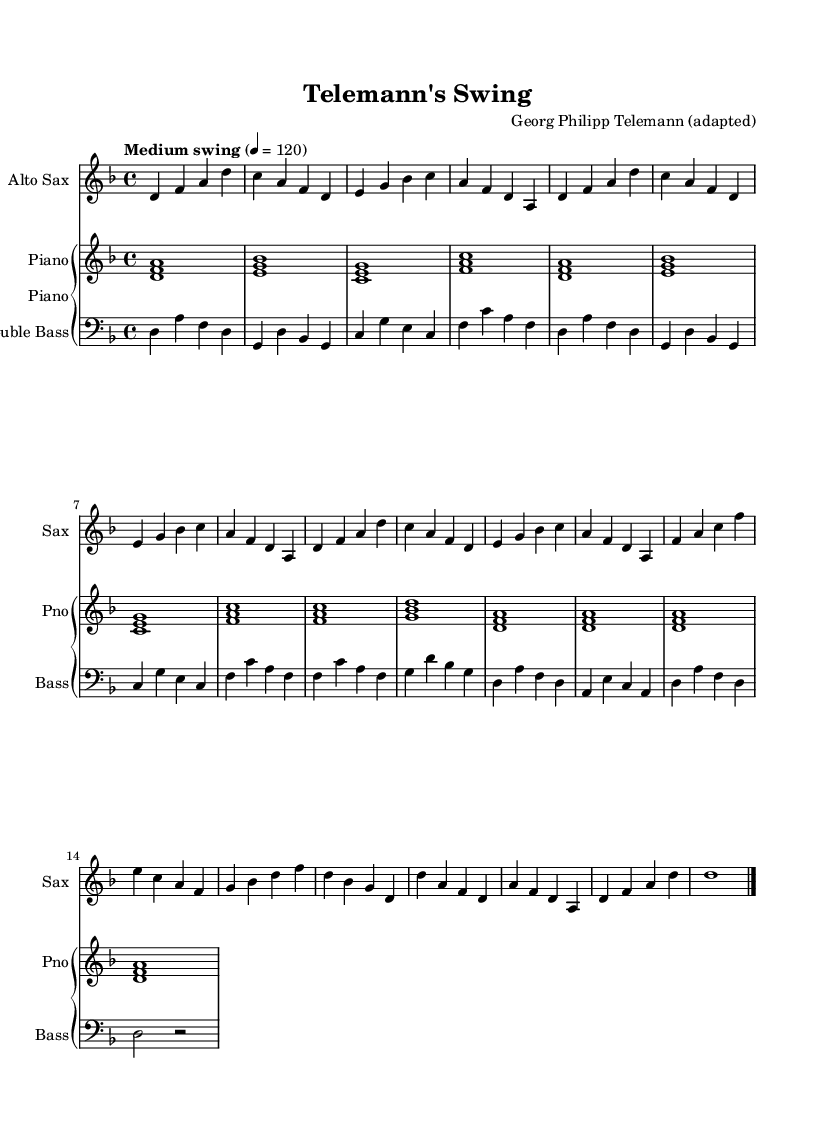What is the key signature of this music? The key signature is indicated by the sharps or flats at the beginning of the staff. In this case, there are no sharps or flats shown, which means it is likely in a key with no alterations, thus the key signature is D minor.
Answer: D minor What is the time signature of this music? The time signature is located at the beginning of the staff and is represented by the numbers written one over the other. Here, it is marked as 4/4, which indicates there are four beats per measure.
Answer: 4/4 What is the tempo marking for this piece? The tempo marking is indicated at the beginning of the score and provides a guideline for the speed of the piece. It states "Medium swing," indicating a moderate swinging style typically associated with jazz music.
Answer: Medium swing How many measures are in the A section? The A section includes the first eight bars indicated above, which can be counted by identifying the measures separated by vertical lines in the staff. There are two repeats of the eight-bar phrase that consist of a total of 8 measures within the A section.
Answer: 8 What instruments are being used in this arrangement? The instruments used are specified at the beginning of each staff in the score. We can see "Alto Sax" for the saxophone, "Piano" for the piano, and "Double Bass" for the bass part.
Answer: Alto Sax, Piano, Double Bass What is the rhythmic feel characterized by "Medium swing"? The term "Medium swing" indicates a rhythmic feel that is typically used in jazz, where the eighth notes are performed in a swung style, creating a triplet feel for pairs of notes and emphasizing the off-beats. This can be deduced from the tempo and style indicated at the beginning.
Answer: Swung eighth notes What kind of harmony is simplified for the piano part? The harmony for the piano part is represented as block chords, indicated by the vertical stacks of notes in the measure. These chords primarily provide a harmonic foundation for the melody played by the saxophone, typically using triads based on the D minor scale.
Answer: Block chords 